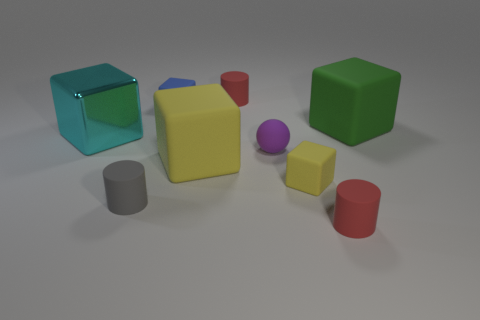Are there any other things that are made of the same material as the purple sphere?
Offer a very short reply. Yes. Is the number of tiny matte objects that are left of the cyan metallic object greater than the number of large yellow things left of the tiny blue block?
Provide a short and direct response. No. How many cylinders have the same material as the sphere?
Offer a very short reply. 3. There is a big green thing that is behind the cyan thing; is its shape the same as the red object behind the purple rubber object?
Provide a succinct answer. No. What color is the small cylinder behind the tiny gray matte object?
Offer a terse response. Red. Is there a tiny matte thing of the same shape as the big yellow matte thing?
Your answer should be compact. Yes. What material is the big yellow cube?
Your response must be concise. Rubber. There is a rubber cube that is left of the large green thing and behind the large metal thing; what size is it?
Ensure brevity in your answer.  Small. What number of large brown rubber things are there?
Ensure brevity in your answer.  0. Are there fewer red matte objects than cyan rubber spheres?
Your response must be concise. No. 